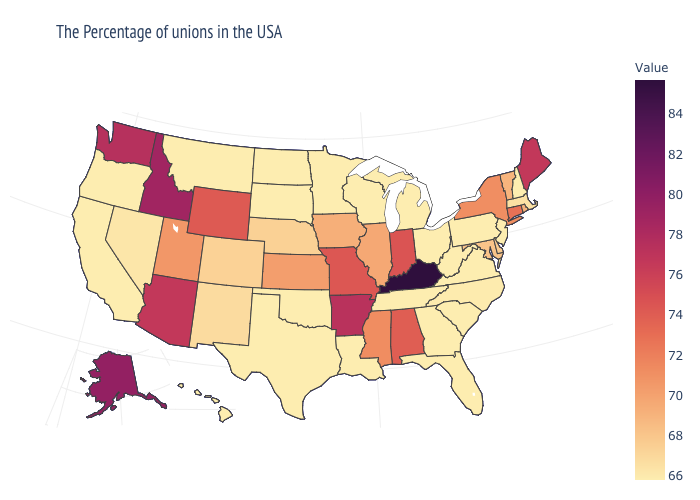Among the states that border Oklahoma , does Arkansas have the highest value?
Concise answer only. Yes. Does Utah have the highest value in the USA?
Be succinct. No. Does Michigan have the lowest value in the MidWest?
Short answer required. Yes. Which states have the highest value in the USA?
Short answer required. Kentucky. Which states have the highest value in the USA?
Be succinct. Kentucky. Does Kentucky have the highest value in the USA?
Write a very short answer. Yes. Among the states that border Connecticut , which have the lowest value?
Answer briefly. Massachusetts. 